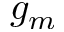<formula> <loc_0><loc_0><loc_500><loc_500>g _ { m }</formula> 